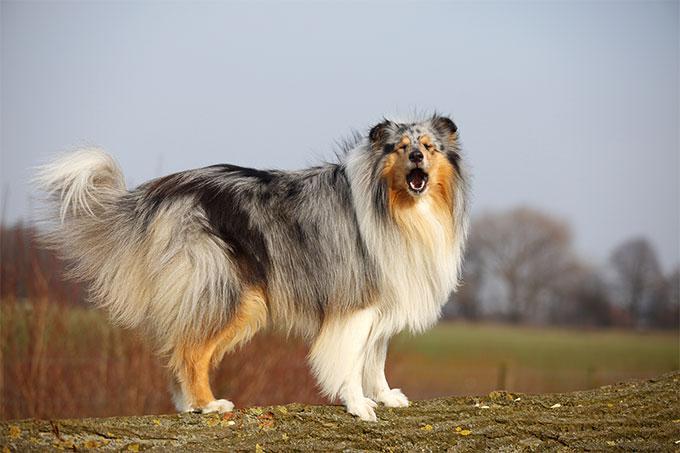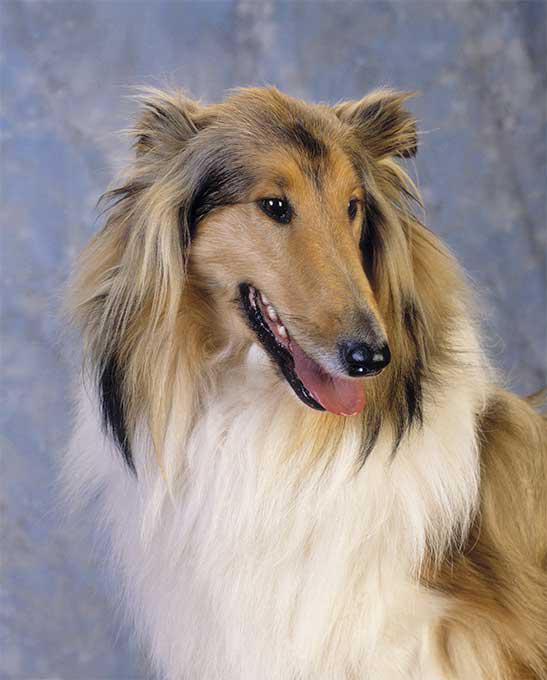The first image is the image on the left, the second image is the image on the right. For the images displayed, is the sentence "There are more then one collie on the right image" factually correct? Answer yes or no. No. 